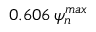Convert formula to latex. <formula><loc_0><loc_0><loc_500><loc_500>0 . 6 0 6 \, \psi _ { n } ^ { \max }</formula> 